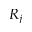Convert formula to latex. <formula><loc_0><loc_0><loc_500><loc_500>R _ { j }</formula> 